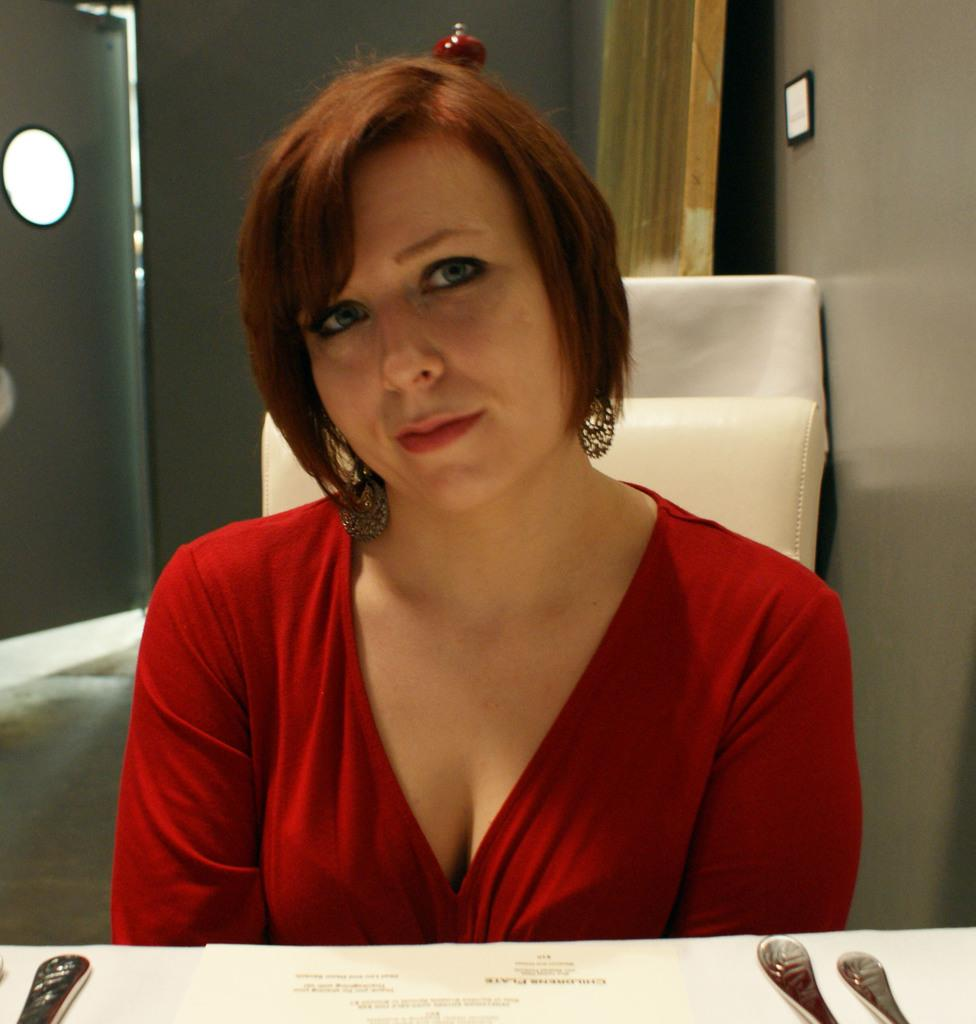What is located at the bottom of the image? There is a table at the bottom of the image. What can be found on the table? A menu card and spoons are visible on the table. Who is present in the image? There is a woman sitting in a chair in the middle of the image. What can be seen in the background of the image? There is a wall and a door in the background of the image. How does the woman express her anger in the image? There is no indication of anger in the image; the woman is simply sitting in a chair. What type of skin is visible on the woman in the image? The image does not provide enough detail to determine the type of skin visible on the woman. 